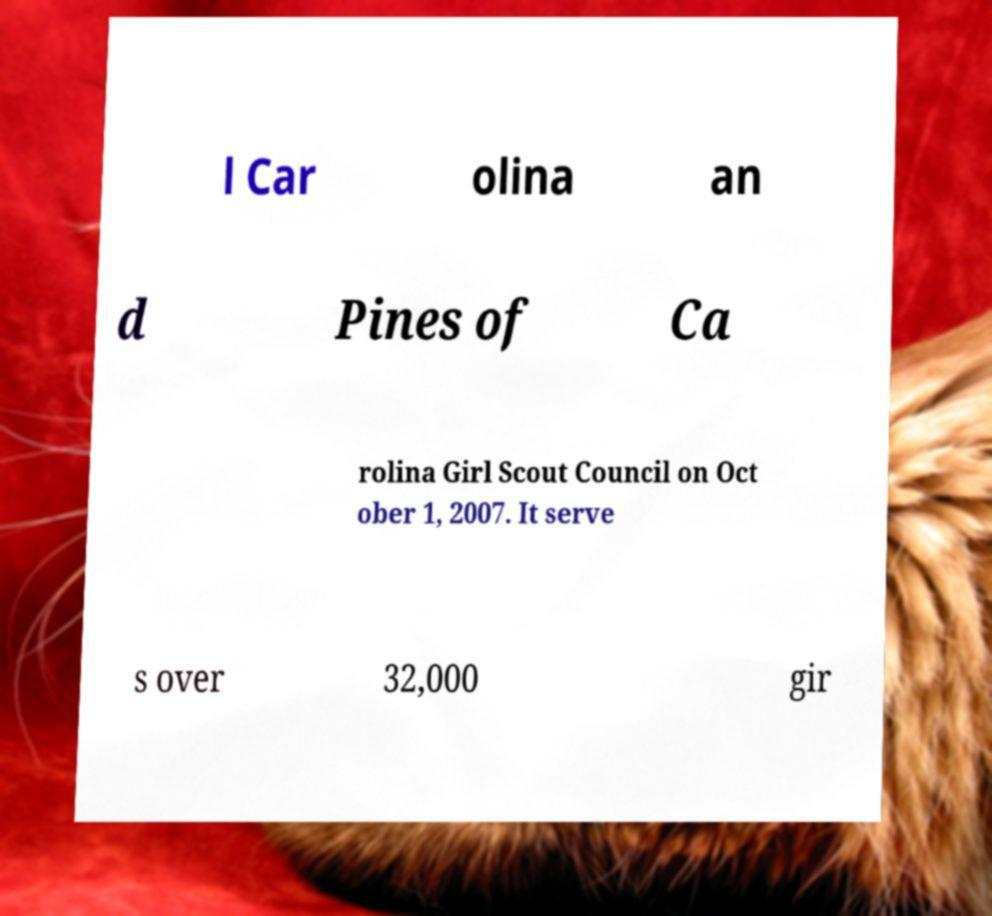Please identify and transcribe the text found in this image. l Car olina an d Pines of Ca rolina Girl Scout Council on Oct ober 1, 2007. It serve s over 32,000 gir 